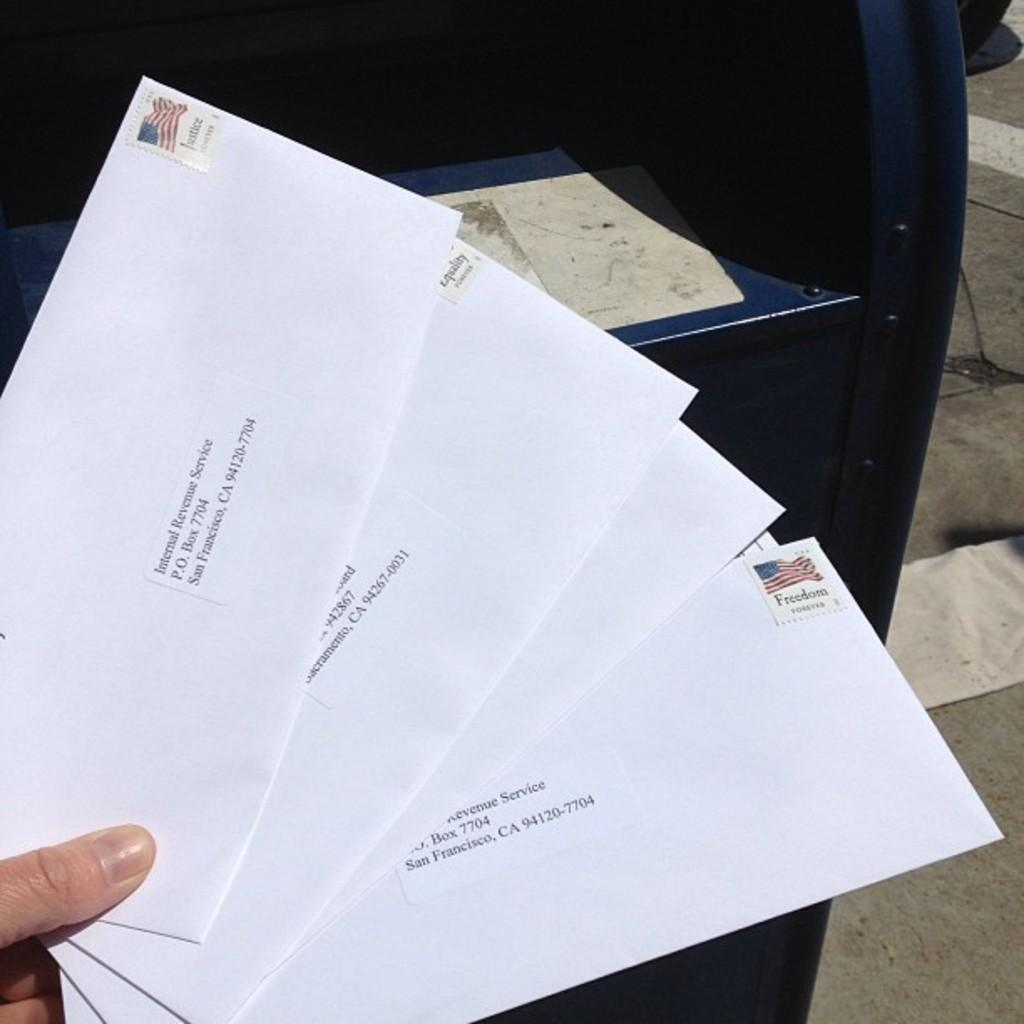Provide a one-sentence caption for the provided image. many envelopes addressed to the Internal Revenue Service in San Francisco. 